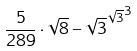<formula> <loc_0><loc_0><loc_500><loc_500>\frac { 5 } { 2 8 9 } \cdot \sqrt { 8 } - { \sqrt { 3 } ^ { \sqrt { 3 } } } ^ { 3 }</formula> 